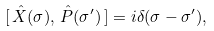<formula> <loc_0><loc_0><loc_500><loc_500>[ \, \hat { X } ( \sigma ) , \, \hat { P } ( \sigma ^ { \prime } ) \, ] = i \delta ( \sigma - \sigma ^ { \prime } ) ,</formula> 